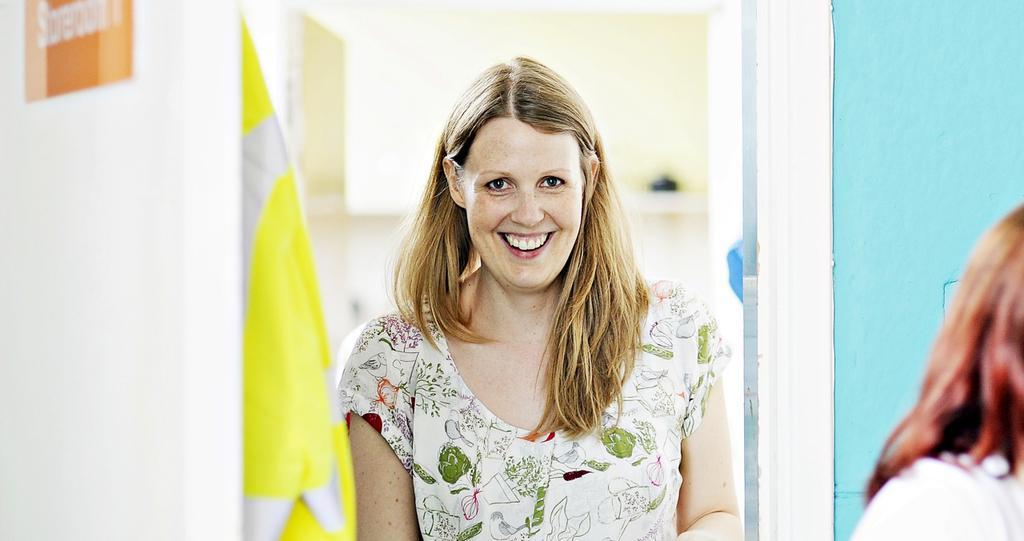Please provide a concise description of this image. There is a woman standing beside a wall, she is smiling by looking into the mirror and beside the mirror there is a blue color wall and there is some yellow cloth beside the woman. 